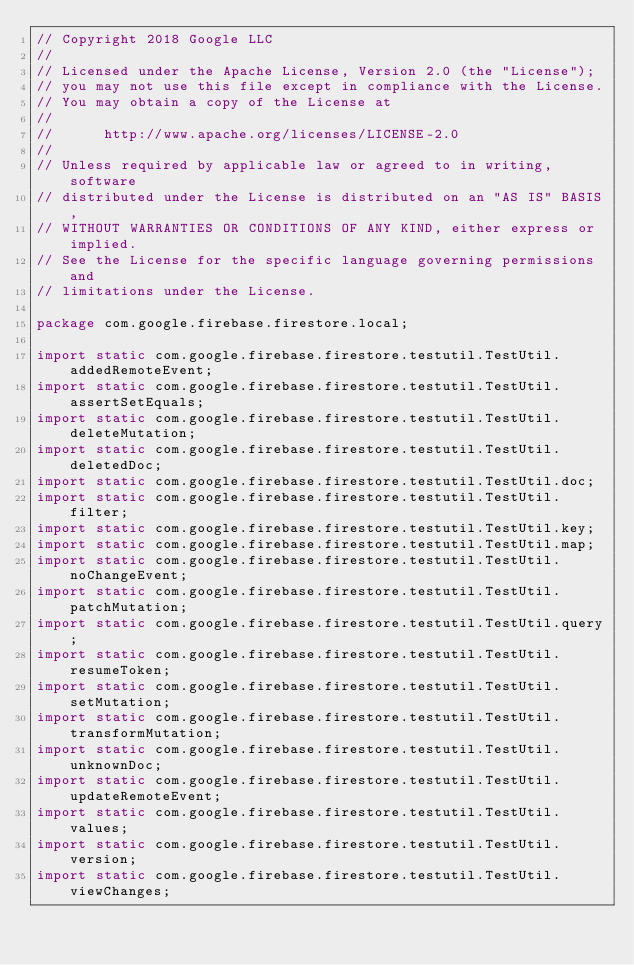<code> <loc_0><loc_0><loc_500><loc_500><_Java_>// Copyright 2018 Google LLC
//
// Licensed under the Apache License, Version 2.0 (the "License");
// you may not use this file except in compliance with the License.
// You may obtain a copy of the License at
//
//      http://www.apache.org/licenses/LICENSE-2.0
//
// Unless required by applicable law or agreed to in writing, software
// distributed under the License is distributed on an "AS IS" BASIS,
// WITHOUT WARRANTIES OR CONDITIONS OF ANY KIND, either express or implied.
// See the License for the specific language governing permissions and
// limitations under the License.

package com.google.firebase.firestore.local;

import static com.google.firebase.firestore.testutil.TestUtil.addedRemoteEvent;
import static com.google.firebase.firestore.testutil.TestUtil.assertSetEquals;
import static com.google.firebase.firestore.testutil.TestUtil.deleteMutation;
import static com.google.firebase.firestore.testutil.TestUtil.deletedDoc;
import static com.google.firebase.firestore.testutil.TestUtil.doc;
import static com.google.firebase.firestore.testutil.TestUtil.filter;
import static com.google.firebase.firestore.testutil.TestUtil.key;
import static com.google.firebase.firestore.testutil.TestUtil.map;
import static com.google.firebase.firestore.testutil.TestUtil.noChangeEvent;
import static com.google.firebase.firestore.testutil.TestUtil.patchMutation;
import static com.google.firebase.firestore.testutil.TestUtil.query;
import static com.google.firebase.firestore.testutil.TestUtil.resumeToken;
import static com.google.firebase.firestore.testutil.TestUtil.setMutation;
import static com.google.firebase.firestore.testutil.TestUtil.transformMutation;
import static com.google.firebase.firestore.testutil.TestUtil.unknownDoc;
import static com.google.firebase.firestore.testutil.TestUtil.updateRemoteEvent;
import static com.google.firebase.firestore.testutil.TestUtil.values;
import static com.google.firebase.firestore.testutil.TestUtil.version;
import static com.google.firebase.firestore.testutil.TestUtil.viewChanges;</code> 